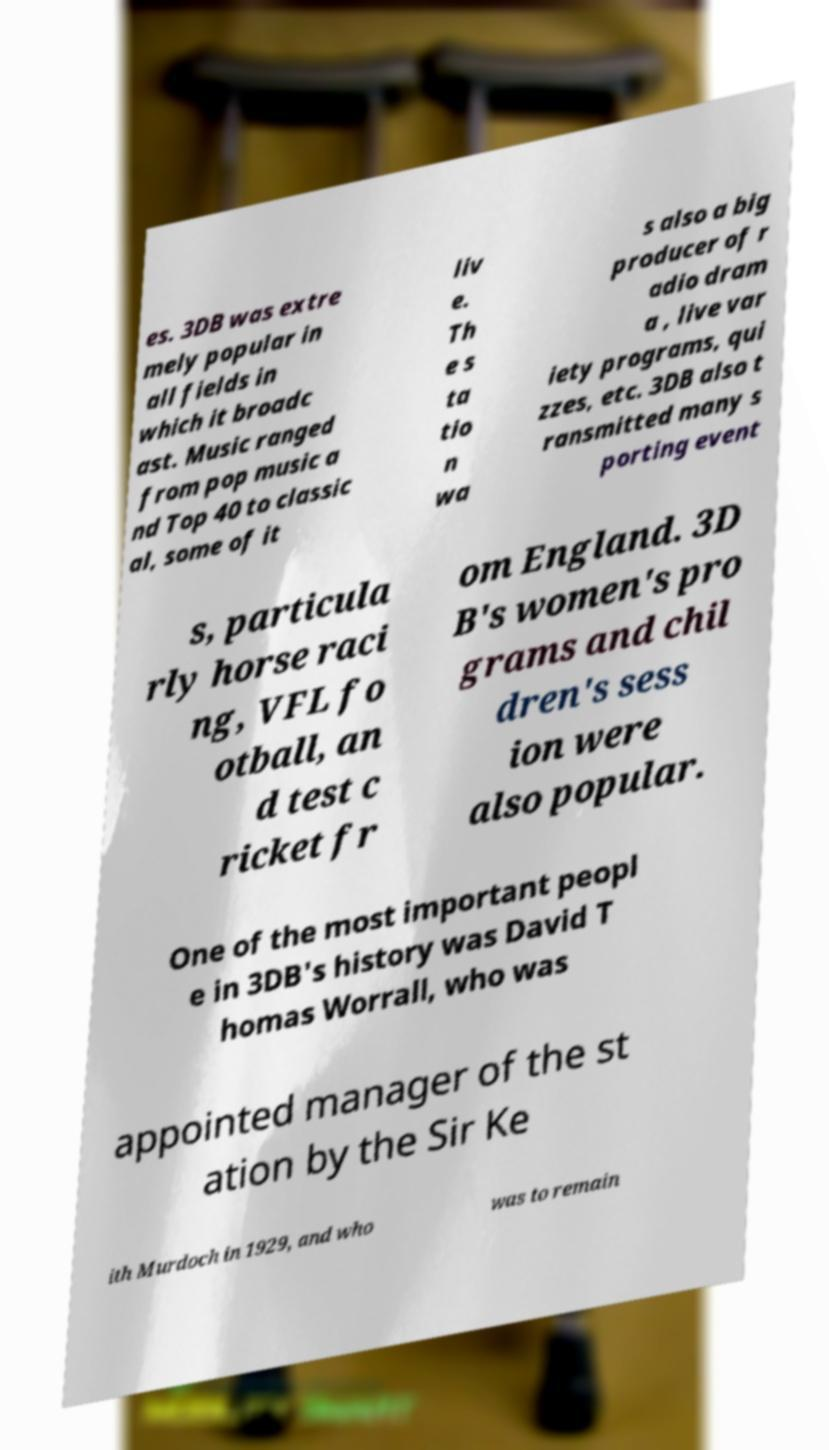There's text embedded in this image that I need extracted. Can you transcribe it verbatim? es. 3DB was extre mely popular in all fields in which it broadc ast. Music ranged from pop music a nd Top 40 to classic al, some of it liv e. Th e s ta tio n wa s also a big producer of r adio dram a , live var iety programs, qui zzes, etc. 3DB also t ransmitted many s porting event s, particula rly horse raci ng, VFL fo otball, an d test c ricket fr om England. 3D B's women's pro grams and chil dren's sess ion were also popular. One of the most important peopl e in 3DB's history was David T homas Worrall, who was appointed manager of the st ation by the Sir Ke ith Murdoch in 1929, and who was to remain 